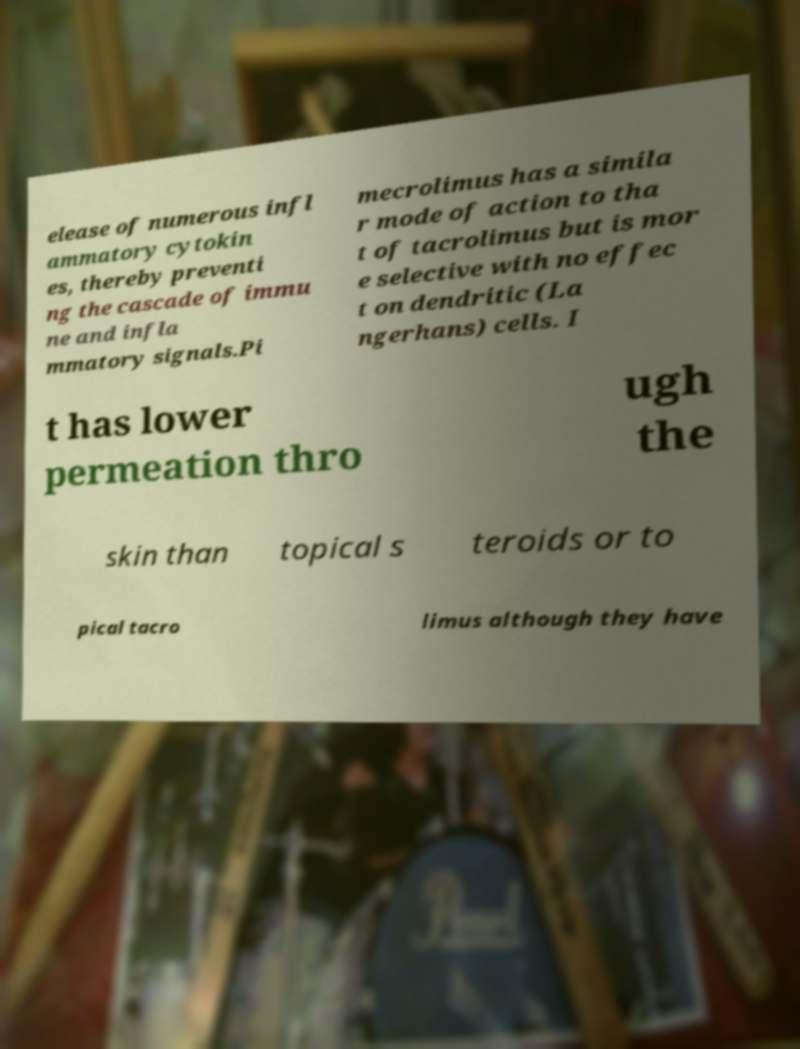Please identify and transcribe the text found in this image. elease of numerous infl ammatory cytokin es, thereby preventi ng the cascade of immu ne and infla mmatory signals.Pi mecrolimus has a simila r mode of action to tha t of tacrolimus but is mor e selective with no effec t on dendritic (La ngerhans) cells. I t has lower permeation thro ugh the skin than topical s teroids or to pical tacro limus although they have 